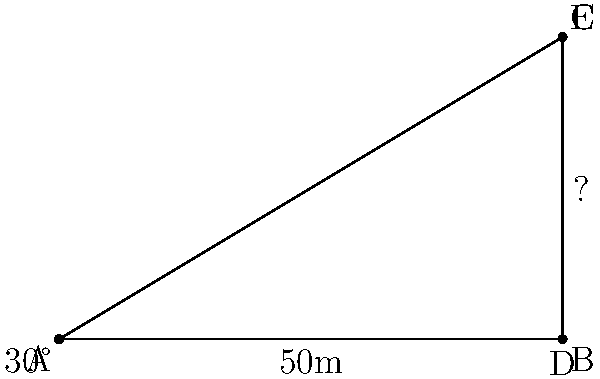In a conflict-affected area, a researcher is studying the impact of warfare on urban infrastructure. They come across the remnants of a destroyed building and want to estimate its original height. Standing at point A, 50 meters away from the base of the building (point B), the researcher measures the angle of elevation to the top of the remaining structure (point C) to be 30°. Using trigonometric ratios, calculate the height of the building. To solve this problem, we'll use the tangent ratio in a right-angled triangle. Here's the step-by-step solution:

1) In a right-angled triangle, tangent of an angle is the ratio of the opposite side to the adjacent side.

   $\tan \theta = \frac{\text{opposite}}{\text{adjacent}}$

2) In this case:
   - The angle $\theta$ is 30°
   - The adjacent side (AB) is 50 meters
   - The opposite side (BC) is the height we're trying to find

3) Let's call the height $h$. We can write:

   $\tan 30° = \frac{h}{50}$

4) To solve for $h$, multiply both sides by 50:

   $50 \tan 30° = h$

5) We know that $\tan 30° = \frac{1}{\sqrt{3}}$, so:

   $h = 50 \cdot \frac{1}{\sqrt{3}}$

6) Simplify:
   
   $h = \frac{50}{\sqrt{3}} \approx 28.87$ meters

Therefore, the height of the building is approximately 28.87 meters.
Answer: 28.87 meters 